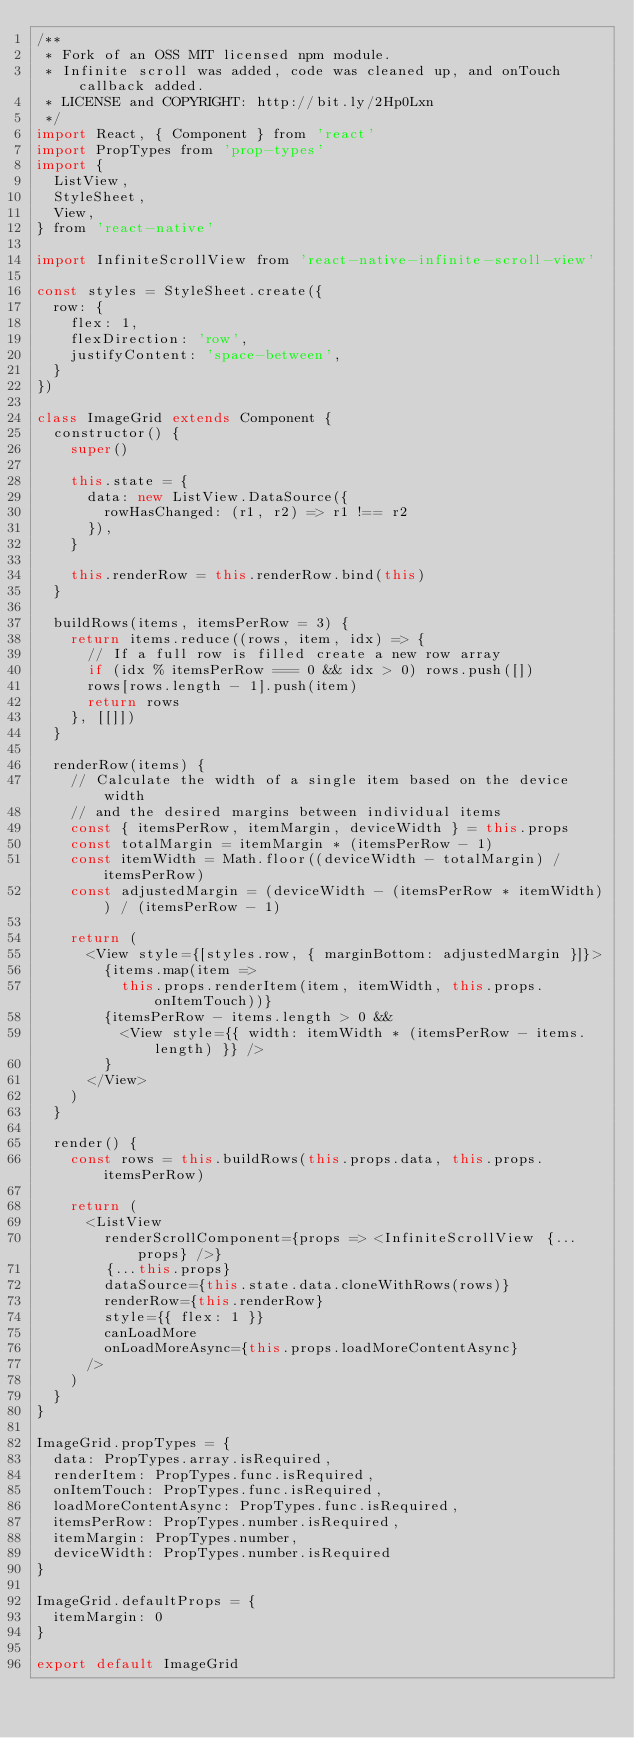Convert code to text. <code><loc_0><loc_0><loc_500><loc_500><_JavaScript_>/**
 * Fork of an OSS MIT licensed npm module.
 * Infinite scroll was added, code was cleaned up, and onTouch callback added.
 * LICENSE and COPYRIGHT: http://bit.ly/2Hp0Lxn
 */
import React, { Component } from 'react'
import PropTypes from 'prop-types'
import {
  ListView,
  StyleSheet,
  View,
} from 'react-native'

import InfiniteScrollView from 'react-native-infinite-scroll-view'

const styles = StyleSheet.create({
  row: {
    flex: 1,
    flexDirection: 'row',
    justifyContent: 'space-between',
  }
})

class ImageGrid extends Component {
  constructor() {
    super()

    this.state = {
      data: new ListView.DataSource({
        rowHasChanged: (r1, r2) => r1 !== r2
      }),
    }

    this.renderRow = this.renderRow.bind(this)
  }

  buildRows(items, itemsPerRow = 3) {
    return items.reduce((rows, item, idx) => {
      // If a full row is filled create a new row array
      if (idx % itemsPerRow === 0 && idx > 0) rows.push([])
      rows[rows.length - 1].push(item)
      return rows
    }, [[]])
  }

  renderRow(items) {
    // Calculate the width of a single item based on the device width
    // and the desired margins between individual items
    const { itemsPerRow, itemMargin, deviceWidth } = this.props
    const totalMargin = itemMargin * (itemsPerRow - 1)
    const itemWidth = Math.floor((deviceWidth - totalMargin) / itemsPerRow)
    const adjustedMargin = (deviceWidth - (itemsPerRow * itemWidth)) / (itemsPerRow - 1)

    return (
      <View style={[styles.row, { marginBottom: adjustedMargin }]}>
        {items.map(item =>
          this.props.renderItem(item, itemWidth, this.props.onItemTouch))}
        {itemsPerRow - items.length > 0 &&
          <View style={{ width: itemWidth * (itemsPerRow - items.length) }} />
        }
      </View>
    )
  }

  render() {
    const rows = this.buildRows(this.props.data, this.props.itemsPerRow)

    return (
      <ListView
        renderScrollComponent={props => <InfiniteScrollView {...props} />}
        {...this.props}
        dataSource={this.state.data.cloneWithRows(rows)}
        renderRow={this.renderRow}
        style={{ flex: 1 }}
        canLoadMore
        onLoadMoreAsync={this.props.loadMoreContentAsync}
      />
    )
  }
}

ImageGrid.propTypes = {
  data: PropTypes.array.isRequired,
  renderItem: PropTypes.func.isRequired,
  onItemTouch: PropTypes.func.isRequired,
  loadMoreContentAsync: PropTypes.func.isRequired,
  itemsPerRow: PropTypes.number.isRequired,
  itemMargin: PropTypes.number,
  deviceWidth: PropTypes.number.isRequired
}

ImageGrid.defaultProps = {
  itemMargin: 0
}

export default ImageGrid
</code> 